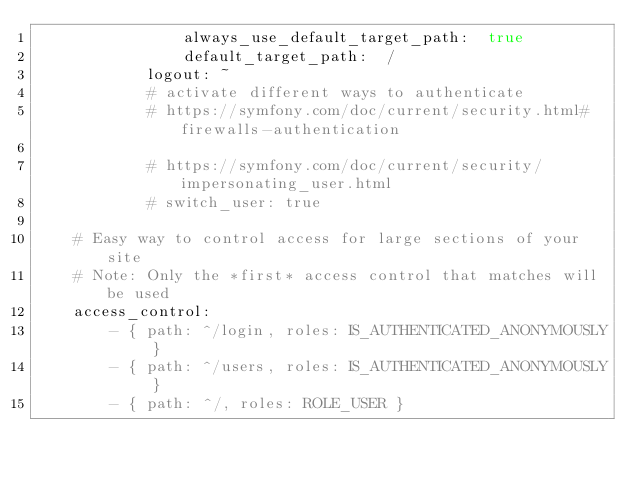<code> <loc_0><loc_0><loc_500><loc_500><_YAML_>                always_use_default_target_path:  true
                default_target_path:  /
            logout: ~
            # activate different ways to authenticate
            # https://symfony.com/doc/current/security.html#firewalls-authentication

            # https://symfony.com/doc/current/security/impersonating_user.html
            # switch_user: true

    # Easy way to control access for large sections of your site
    # Note: Only the *first* access control that matches will be used
    access_control:
        - { path: ^/login, roles: IS_AUTHENTICATED_ANONYMOUSLY }
        - { path: ^/users, roles: IS_AUTHENTICATED_ANONYMOUSLY }
        - { path: ^/, roles: ROLE_USER }
</code> 